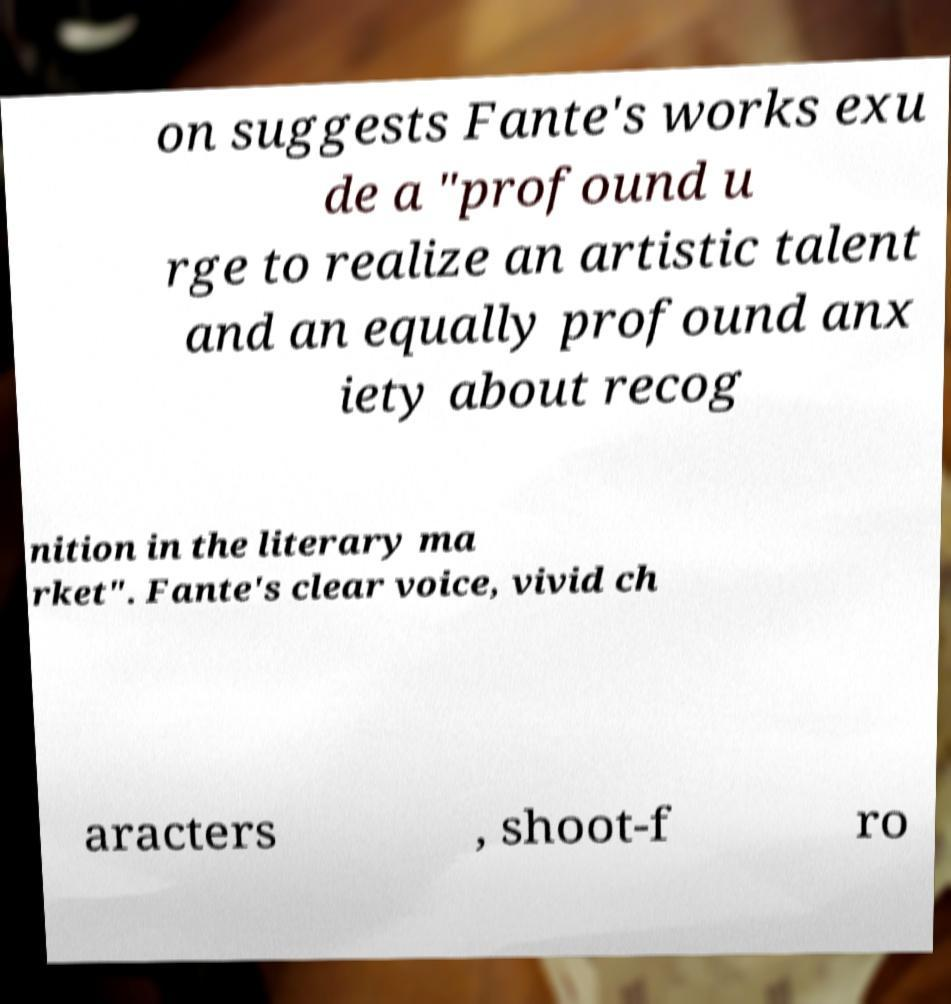I need the written content from this picture converted into text. Can you do that? on suggests Fante's works exu de a "profound u rge to realize an artistic talent and an equally profound anx iety about recog nition in the literary ma rket". Fante's clear voice, vivid ch aracters , shoot-f ro 